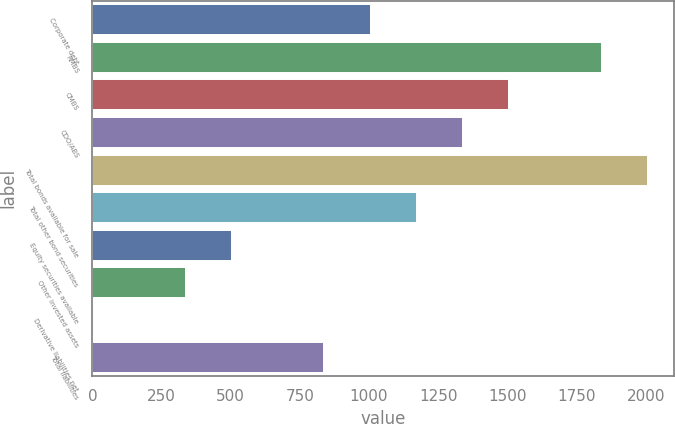<chart> <loc_0><loc_0><loc_500><loc_500><bar_chart><fcel>Corporate debt<fcel>RMBS<fcel>CMBS<fcel>CDO/ABS<fcel>Total bonds available for sale<fcel>Total other bond securities<fcel>Equity securities available<fcel>Other invested assets<fcel>Derivative liabilities net<fcel>Total liabilities<nl><fcel>1002.4<fcel>1836.9<fcel>1503.1<fcel>1336.2<fcel>2003.8<fcel>1169.3<fcel>501.7<fcel>334.8<fcel>1<fcel>835.5<nl></chart> 